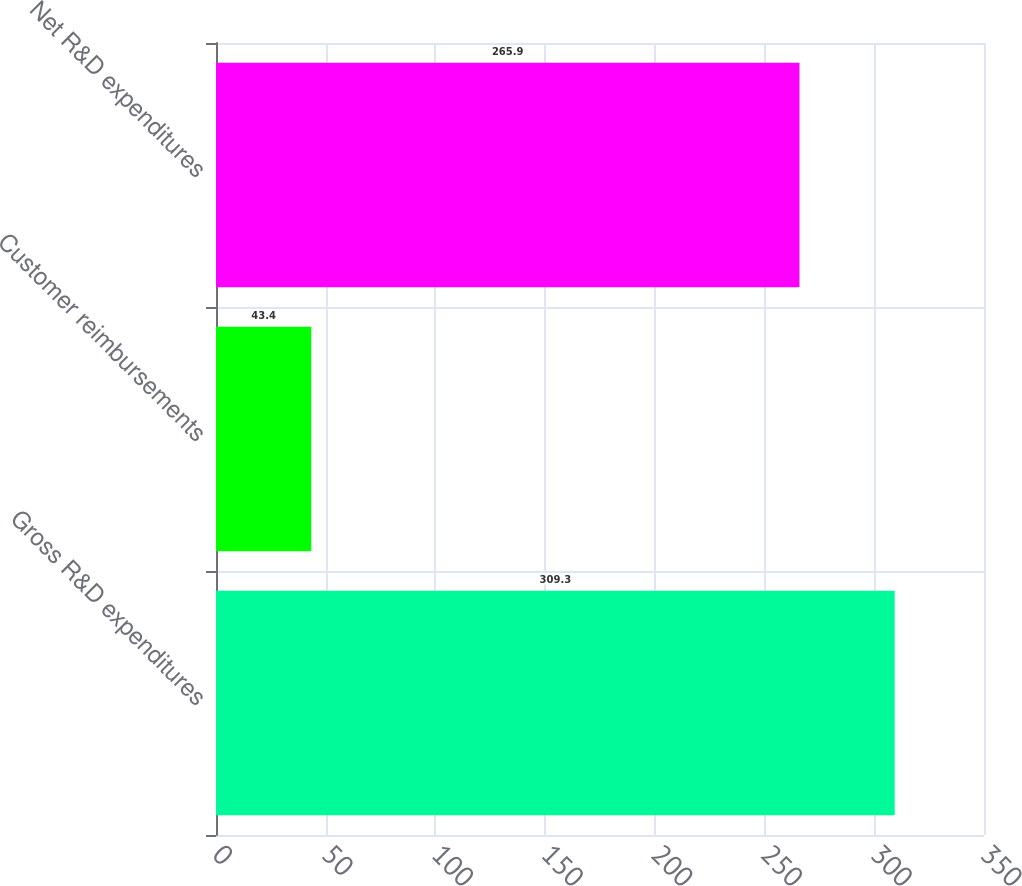Convert chart. <chart><loc_0><loc_0><loc_500><loc_500><bar_chart><fcel>Gross R&D expenditures<fcel>Customer reimbursements<fcel>Net R&D expenditures<nl><fcel>309.3<fcel>43.4<fcel>265.9<nl></chart> 